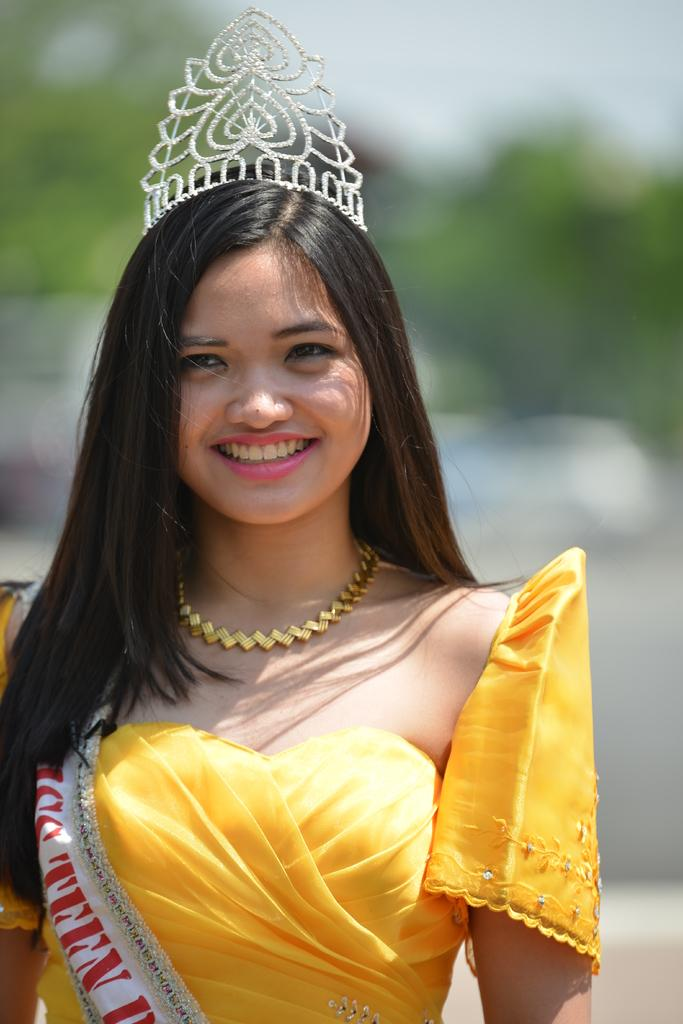Who is present in the image? There is a woman in the image. What is the woman doing in the image? The woman is smiling in the image. What accessories is the woman wearing in the image? The woman is wearing a crown on her head and a sash in the image. Can you describe the background of the image? The background of the image has a blurred view. What type of mine can be seen in the background of the image? There is no mine present in the background of the image. How many beds are visible in the image? There are no beds visible in the image. 